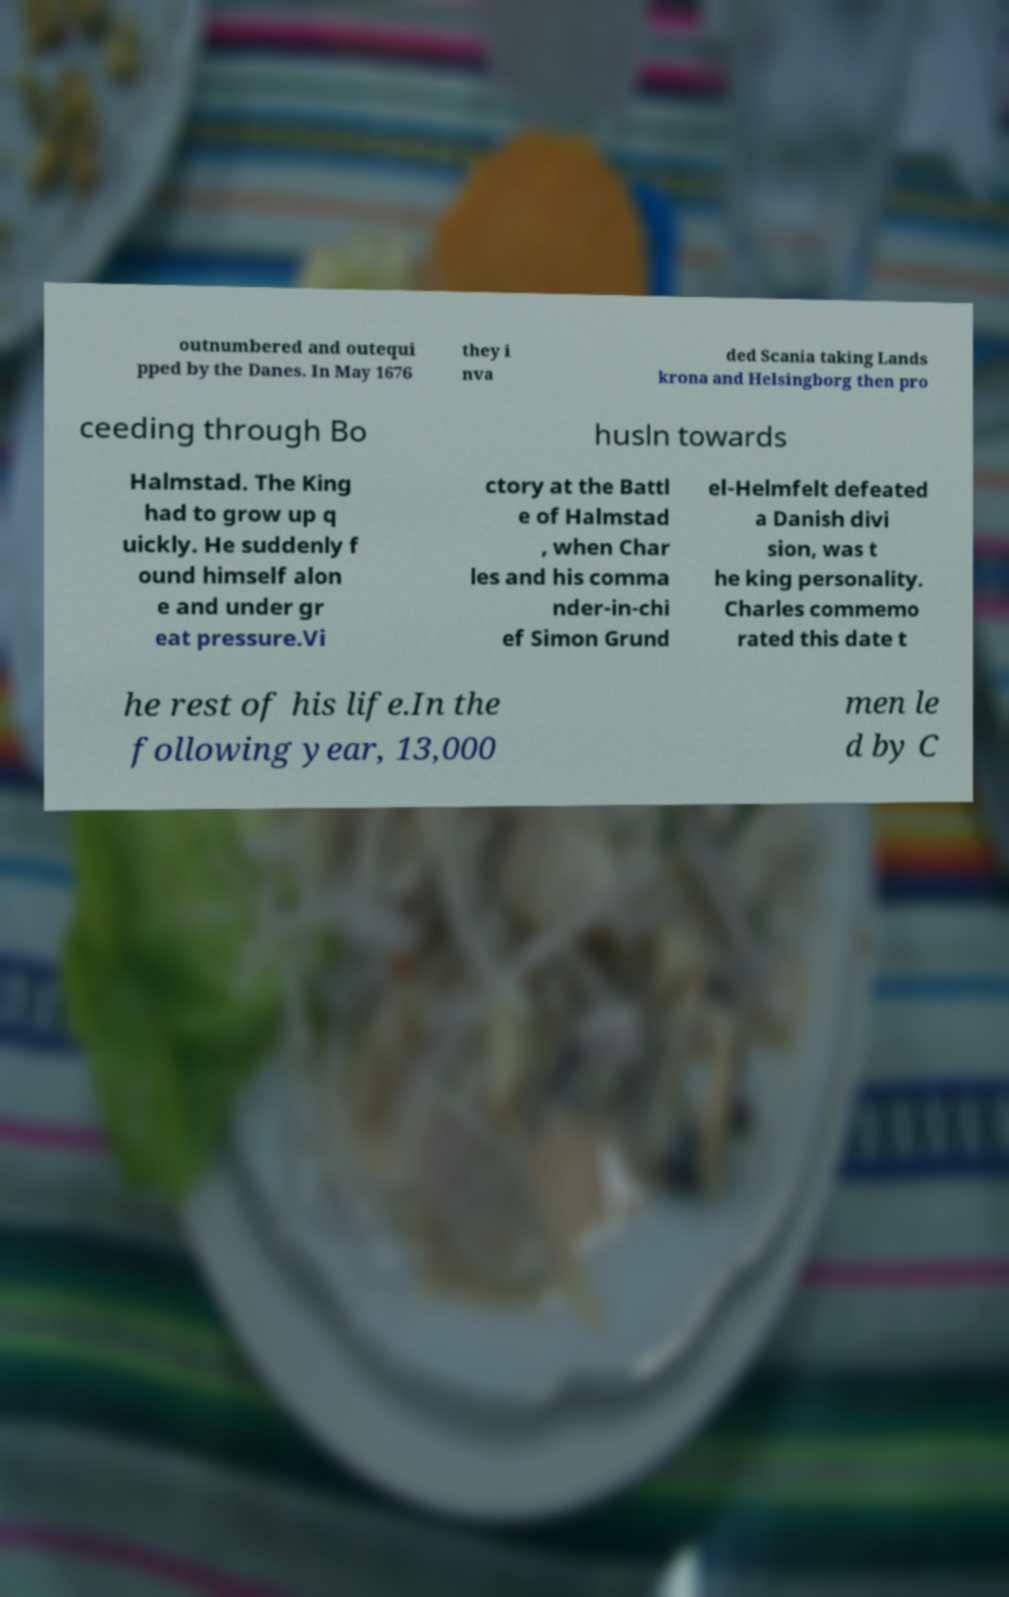Could you assist in decoding the text presented in this image and type it out clearly? outnumbered and outequi pped by the Danes. In May 1676 they i nva ded Scania taking Lands krona and Helsingborg then pro ceeding through Bo husln towards Halmstad. The King had to grow up q uickly. He suddenly f ound himself alon e and under gr eat pressure.Vi ctory at the Battl e of Halmstad , when Char les and his comma nder-in-chi ef Simon Grund el-Helmfelt defeated a Danish divi sion, was t he king personality. Charles commemo rated this date t he rest of his life.In the following year, 13,000 men le d by C 